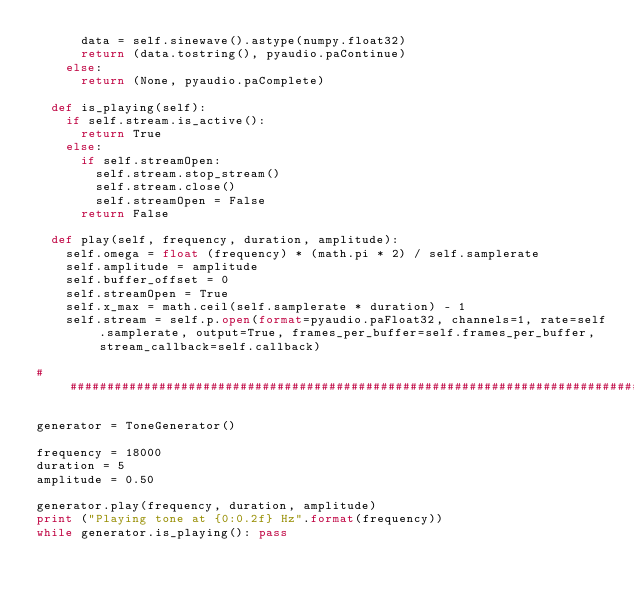<code> <loc_0><loc_0><loc_500><loc_500><_Python_>			data = self.sinewave().astype(numpy.float32)
			return (data.tostring(), pyaudio.paContinue)
		else:
			return (None, pyaudio.paComplete)
	
	def is_playing(self):
		if self.stream.is_active():
			return True
		else:
			if self.streamOpen:
				self.stream.stop_stream()
				self.stream.close()
				self.streamOpen = False
			return False

	def play(self, frequency, duration, amplitude):
		self.omega = float (frequency) * (math.pi * 2) / self.samplerate
		self.amplitude = amplitude
		self.buffer_offset = 0
		self.streamOpen = True
		self.x_max = math.ceil(self.samplerate * duration) - 1
		self.stream = self.p.open(format=pyaudio.paFloat32, channels=1, rate=self.samplerate, output=True, frames_per_buffer=self.frames_per_buffer, stream_callback=self.callback)

###########################################################################################################

generator = ToneGenerator()

frequency = 18000
duration = 5
amplitude = 0.50

generator.play(frequency, duration, amplitude)
print ("Playing tone at {0:0.2f} Hz".format(frequency))
while generator.is_playing(): pass
</code> 